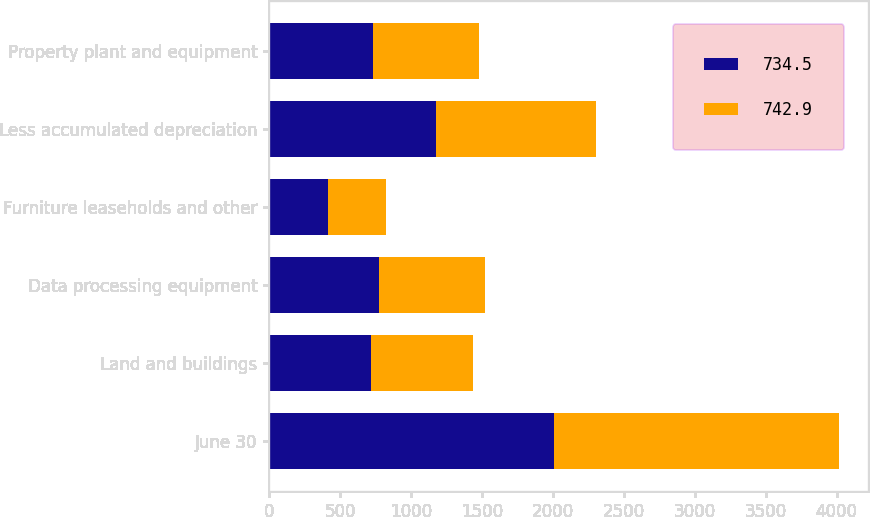Convert chart to OTSL. <chart><loc_0><loc_0><loc_500><loc_500><stacked_bar_chart><ecel><fcel>June 30<fcel>Land and buildings<fcel>Data processing equipment<fcel>Furniture leaseholds and other<fcel>Less accumulated depreciation<fcel>Property plant and equipment<nl><fcel>734.5<fcel>2009<fcel>721.1<fcel>771.3<fcel>417.9<fcel>1175.8<fcel>734.5<nl><fcel>742.9<fcel>2008<fcel>714.3<fcel>747.3<fcel>407.8<fcel>1126.5<fcel>742.9<nl></chart> 